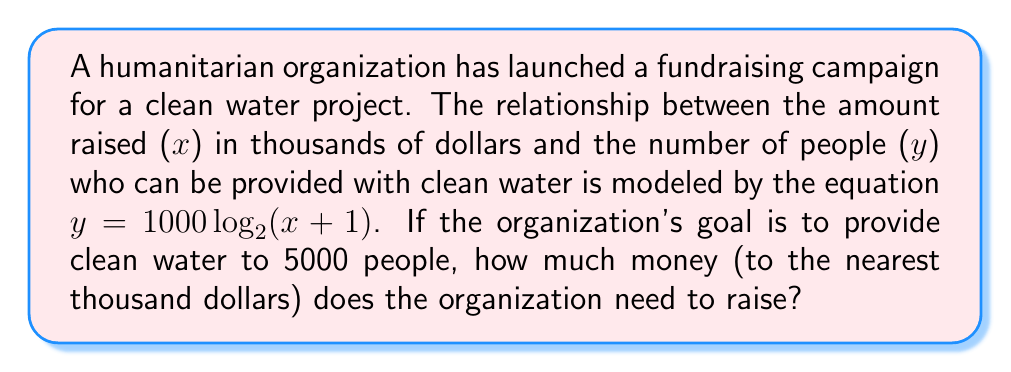Solve this math problem. Let's approach this step-by-step:

1) We're given the equation $y = 1000 \log_2(x + 1)$, where:
   - y is the number of people who can be provided with clean water
   - x is the amount raised in thousands of dollars

2) We need to find x when y = 5000. Let's substitute this into our equation:

   $5000 = 1000 \log_2(x + 1)$

3) Divide both sides by 1000:

   $5 = \log_2(x + 1)$

4) To solve for x, we need to apply the inverse function (exponential) to both sides:

   $2^5 = x + 1$

5) Calculate $2^5$:

   $32 = x + 1$

6) Subtract 1 from both sides:

   $31 = x$

7) Remember, x was in thousands of dollars. So the actual amount is $31,000.

8) Rounding to the nearest thousand dollars, the answer remains $31,000.
Answer: $31,000 